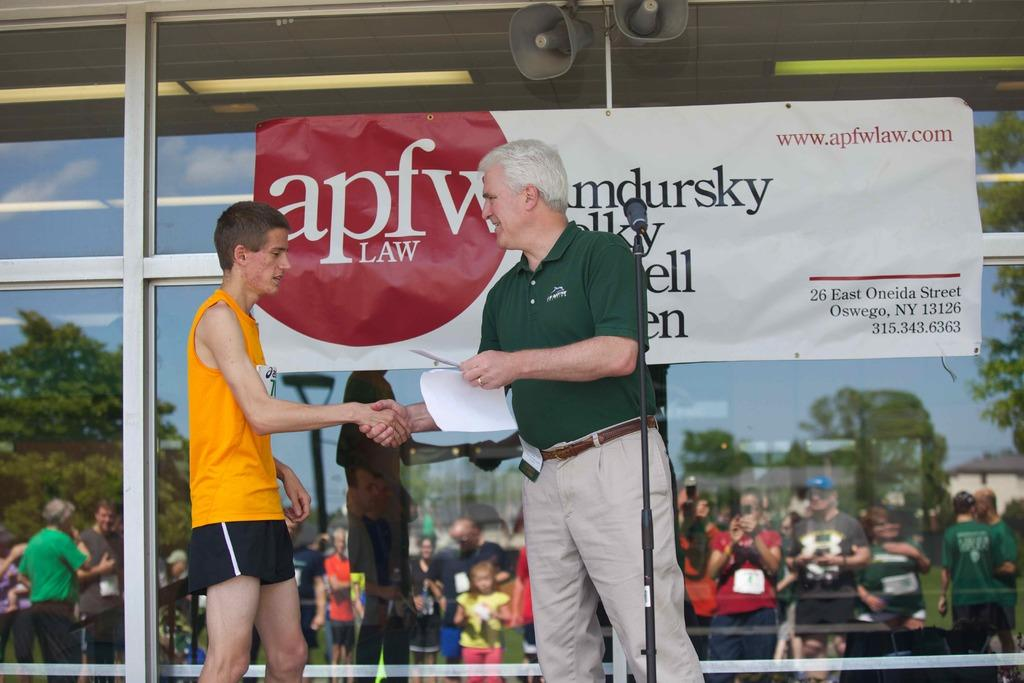<image>
Relay a brief, clear account of the picture shown. the word law is on a poster behind two people 